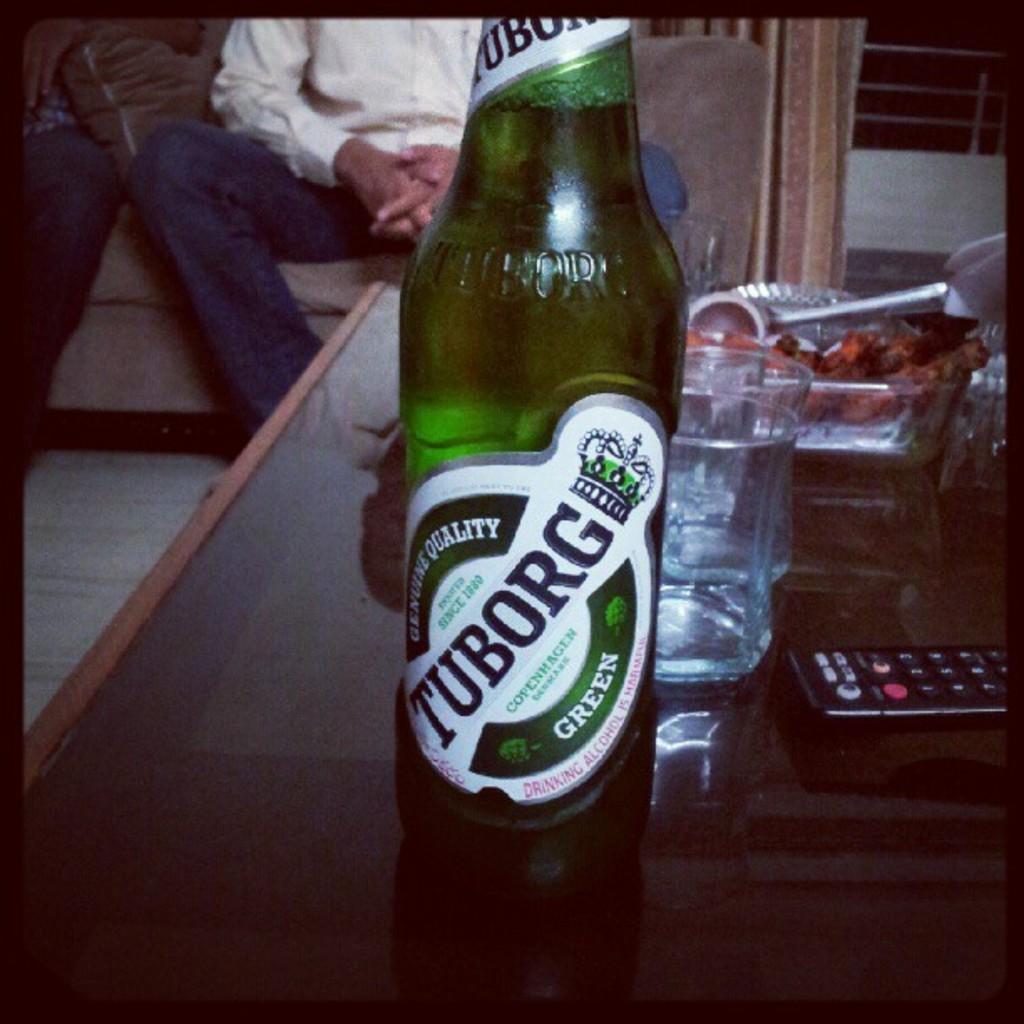What kind of beer is this?
Your answer should be compact. Tuborg. What color is this beer?
Offer a terse response. Green. 